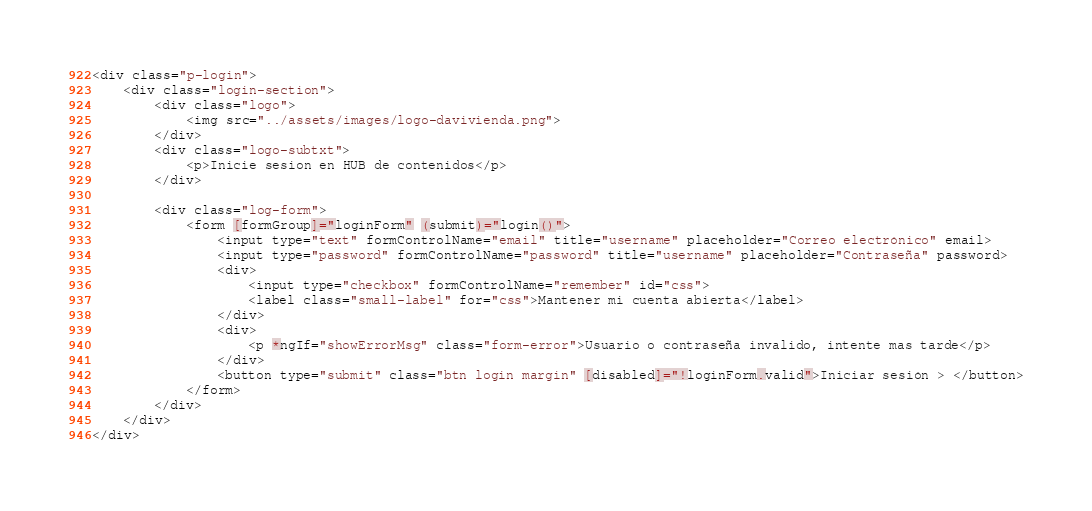<code> <loc_0><loc_0><loc_500><loc_500><_HTML_><div class="p-login">
    <div class="login-section">
        <div class="logo">
            <img src="../assets/images/logo-davivienda.png">
        </div>
        <div class="logo-subtxt">
            <p>Inicie sesion en HUB de contenidos</p>
        </div>

        <div class="log-form">
            <form [formGroup]="loginForm" (submit)="login()">
                <input type="text" formControlName="email" title="username" placeholder="Correo electrónico" email>
                <input type="password" formControlName="password" title="username" placeholder="Contraseña" password>
                <div>
                    <input type="checkbox" formControlName="remember" id="css">
                    <label class="small-label" for="css">Mantener mi cuenta abierta</label>
                </div>
                <div>
                    <p *ngIf="showErrorMsg" class="form-error">Usuario o contraseña invalido, intente mas tarde</p>
                </div>
                <button type="submit" class="btn login margin" [disabled]="!loginForm.valid">Iniciar sesión > </button>
            </form>
        </div>
    </div>
</div>
</code> 